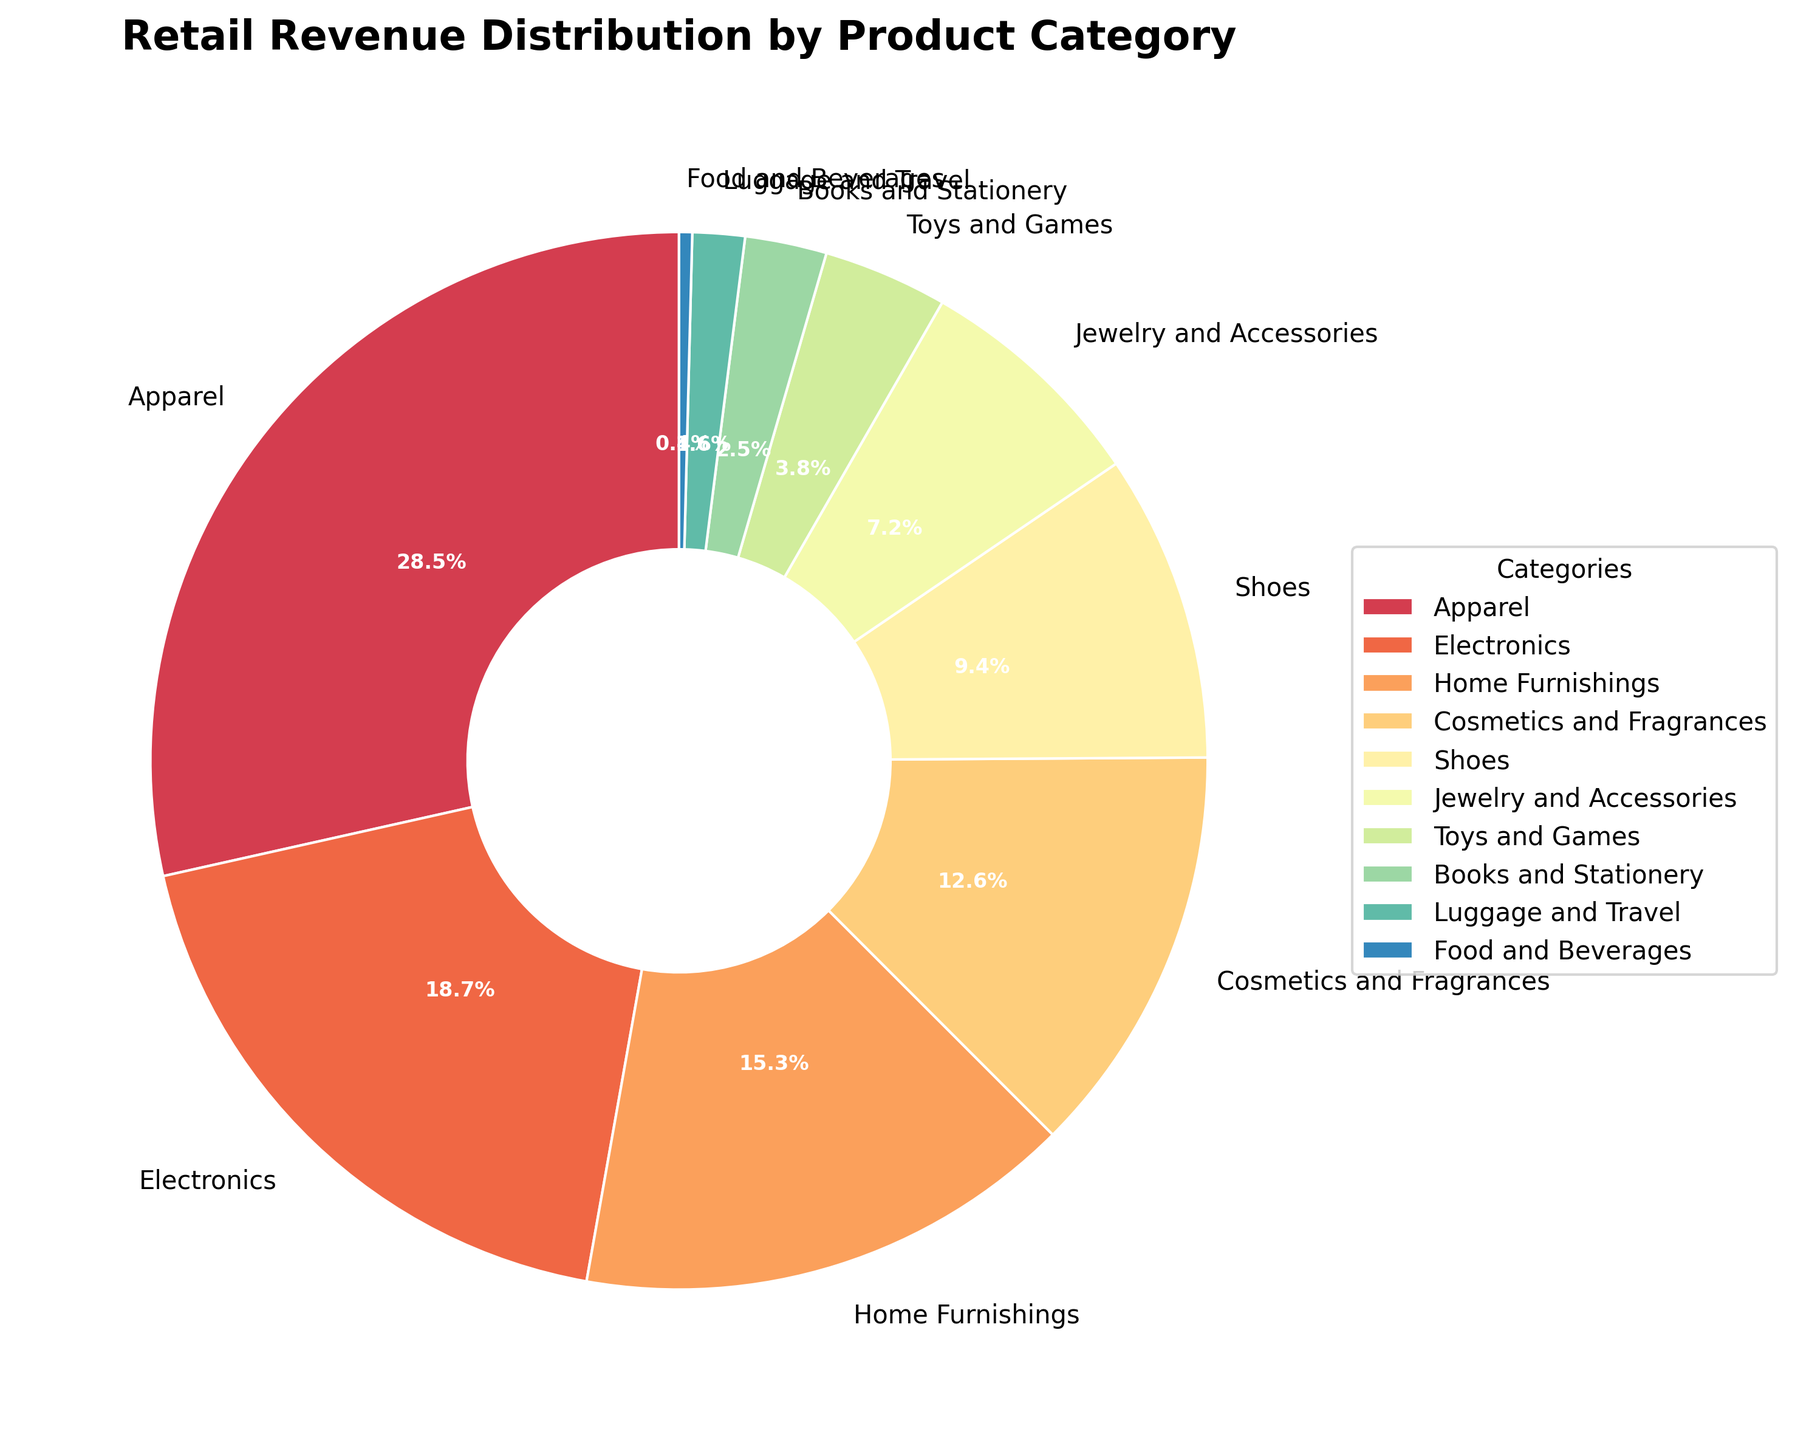What is the largest revenue category? By referring to the pie chart, the segment labeled "Apparel" has the highest percentage value which is 28.5%.
Answer: Apparel How much greater is the revenue from Apparel compared to Electronics? Subtract the percentage of Electronics from that of Apparel: 28.5% - 18.7% = 9.8%.
Answer: 9.8% Which category has the smallest revenue percentage? By looking at the pie chart, the segment labeled "Food and Beverages" has the smallest percentage value, which is 0.4%.
Answer: Food and Beverages What is the combined revenue percentage for Cosmetics and Fragrances and Jewelry and Accessories? Add the percentage values of Cosmetics and Fragrances (12.6%) and Jewelry and Accessories (7.2%): 12.6% + 7.2% = 19.8%.
Answer: 19.8% Which categories have a revenue percentage close to 15%? The pie chart shows that "Home Furnishings" has a revenue percentage of 15.3%, which is close to 15%.
Answer: Home Furnishings How many categories contribute less than 5% to the total revenue? From the pie chart, the categories with less than 5% are Toys and Games (3.8%), Books and Stationery (2.5%), Luggage and Travel (1.6%), and Food and Beverages (0.4%). Counting these gives 4 categories.
Answer: 4 Which color shade corresponds to the Electronics category in the pie chart? Observing the visualization, the Electronics segment is colored with a shade from the provided colormap, particularly a distinct color in the Spectral scheme.
Answer: (Answer based on the actual color observed in the pie chart) How does the sum of the revenue percentages for Apparel, Shoes, and Jewelry and Accessories compare to the total percentage of 100%? Summing the percentages for Apparel (28.5%), Shoes (9.4%), and Jewelry and Accessories (7.2%) gives: 28.5% + 9.4% + 7.2% = 45.1%. This is less than 100%.
Answer: Less than 100% What is the difference between the revenue percentages of Apparel and the sum of Books and Stationery and Luggage and Travel? Calculate the sum of Books and Stationery (2.5%) and Luggage and Travel (1.6%) first, which is 2.5% + 1.6% = 4.1%, then subtract this from Apparel: 28.5% - 4.1% = 24.4%.
Answer: 24.4% What portion of the total revenue is generated by the top three categories? The top three categories by revenue percentage are Apparel (28.5%), Electronics (18.7%), and Home Furnishings (15.3%). Adding these gives: 28.5% + 18.7% + 15.3% = 62.5%.
Answer: 62.5% 